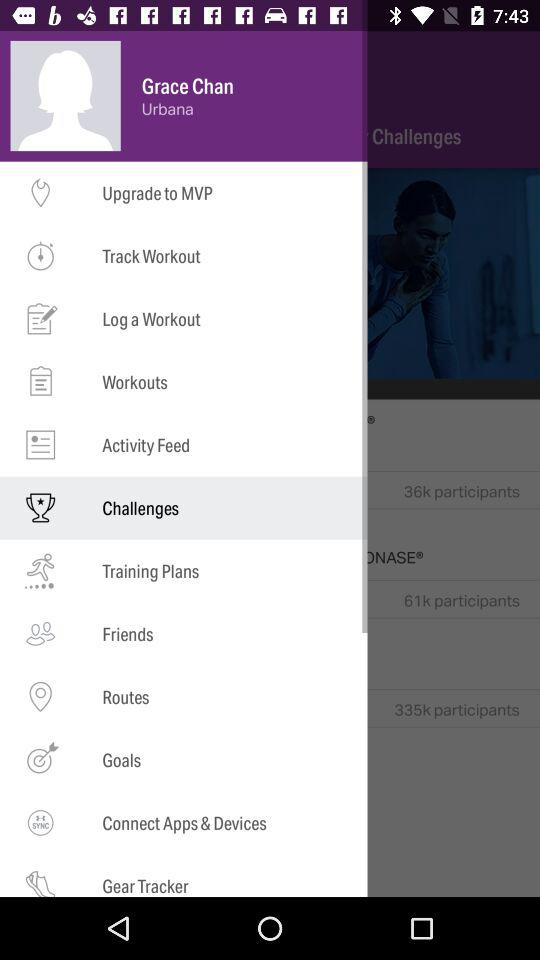Which item is selected? The selected item is "Challenges". 